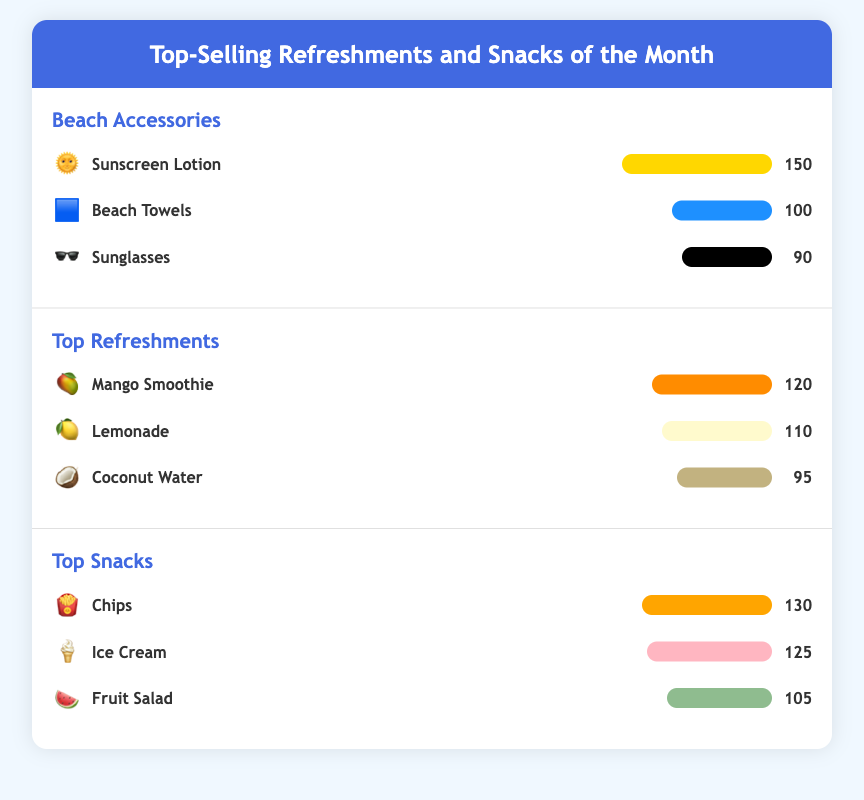What is the top-selling beach accessory? The top-selling beach accessory is Sunscreen Lotion with 150 sales.
Answer: Sunscreen Lotion How many beach towels were sold? The number of beach towels sold is displayed in the document, which is 100.
Answer: 100 Which snack had the lowest sales? The snack with the lowest sales is Fruit Salad with 105 sales.
Answer: Fruit Salad What is the sales figure for Ice Cream? The sales figure for Ice Cream is specifically listed in the document as 125.
Answer: 125 Name one top-selling refreshment. One of the top-selling refreshments is Mango Smoothie, which has 120 sales.
Answer: Mango Smoothie What icon represents Coconut Water? The icon representing Coconut Water is a Coconut emoji.
Answer: 🥥 How many snacks had sales over 120? The total number of snacks with over 120 sales is two, which are Chips and Ice Cream.
Answer: 2 What color represents the bar for Lemonade? The bar for Lemonade is colored a light yellow.
Answer: #FFFACD Which section has the highest sales? The section with the highest sales is Beach Accessories with a total of 340 sales.
Answer: Beach Accessories 